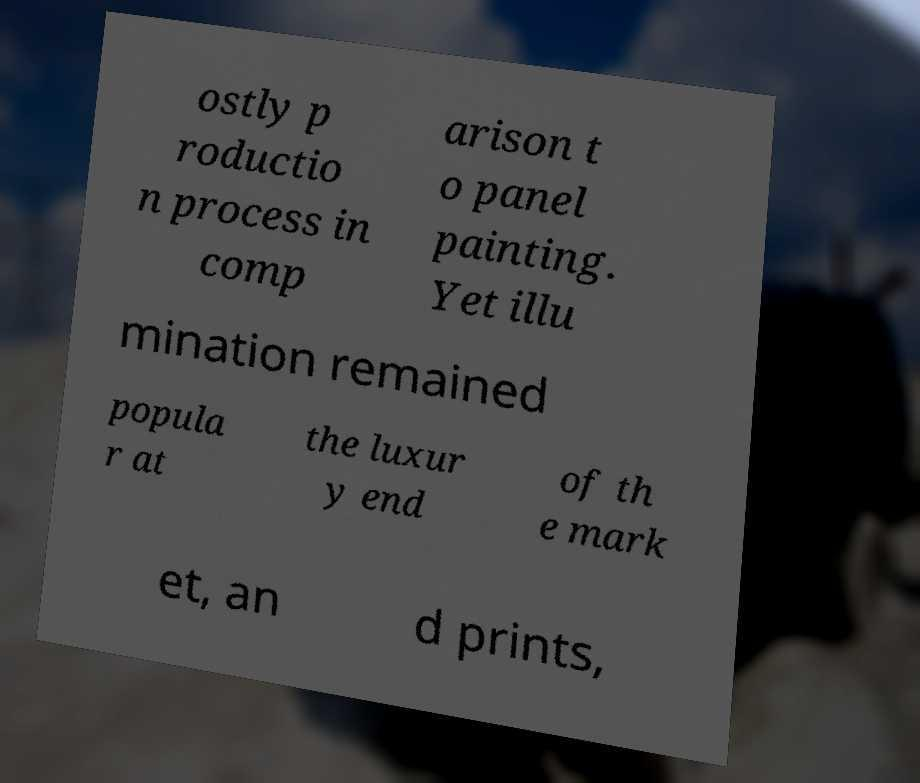Could you extract and type out the text from this image? ostly p roductio n process in comp arison t o panel painting. Yet illu mination remained popula r at the luxur y end of th e mark et, an d prints, 